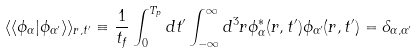<formula> <loc_0><loc_0><loc_500><loc_500>\langle \langle \phi _ { \alpha } | \phi _ { \alpha ^ { \prime } } \rangle \rangle _ { r , t ^ { \prime } } \equiv \frac { 1 } { t _ { f } } \int _ { 0 } ^ { T _ { p } } d t ^ { \prime } \int _ { - \infty } ^ { \infty } d ^ { 3 } r \phi ^ { * } _ { \alpha } ( r , t ^ { \prime } ) \phi _ { \alpha ^ { \prime } } ( r , t ^ { \prime } ) = \delta _ { \alpha , \alpha ^ { \prime } }</formula> 